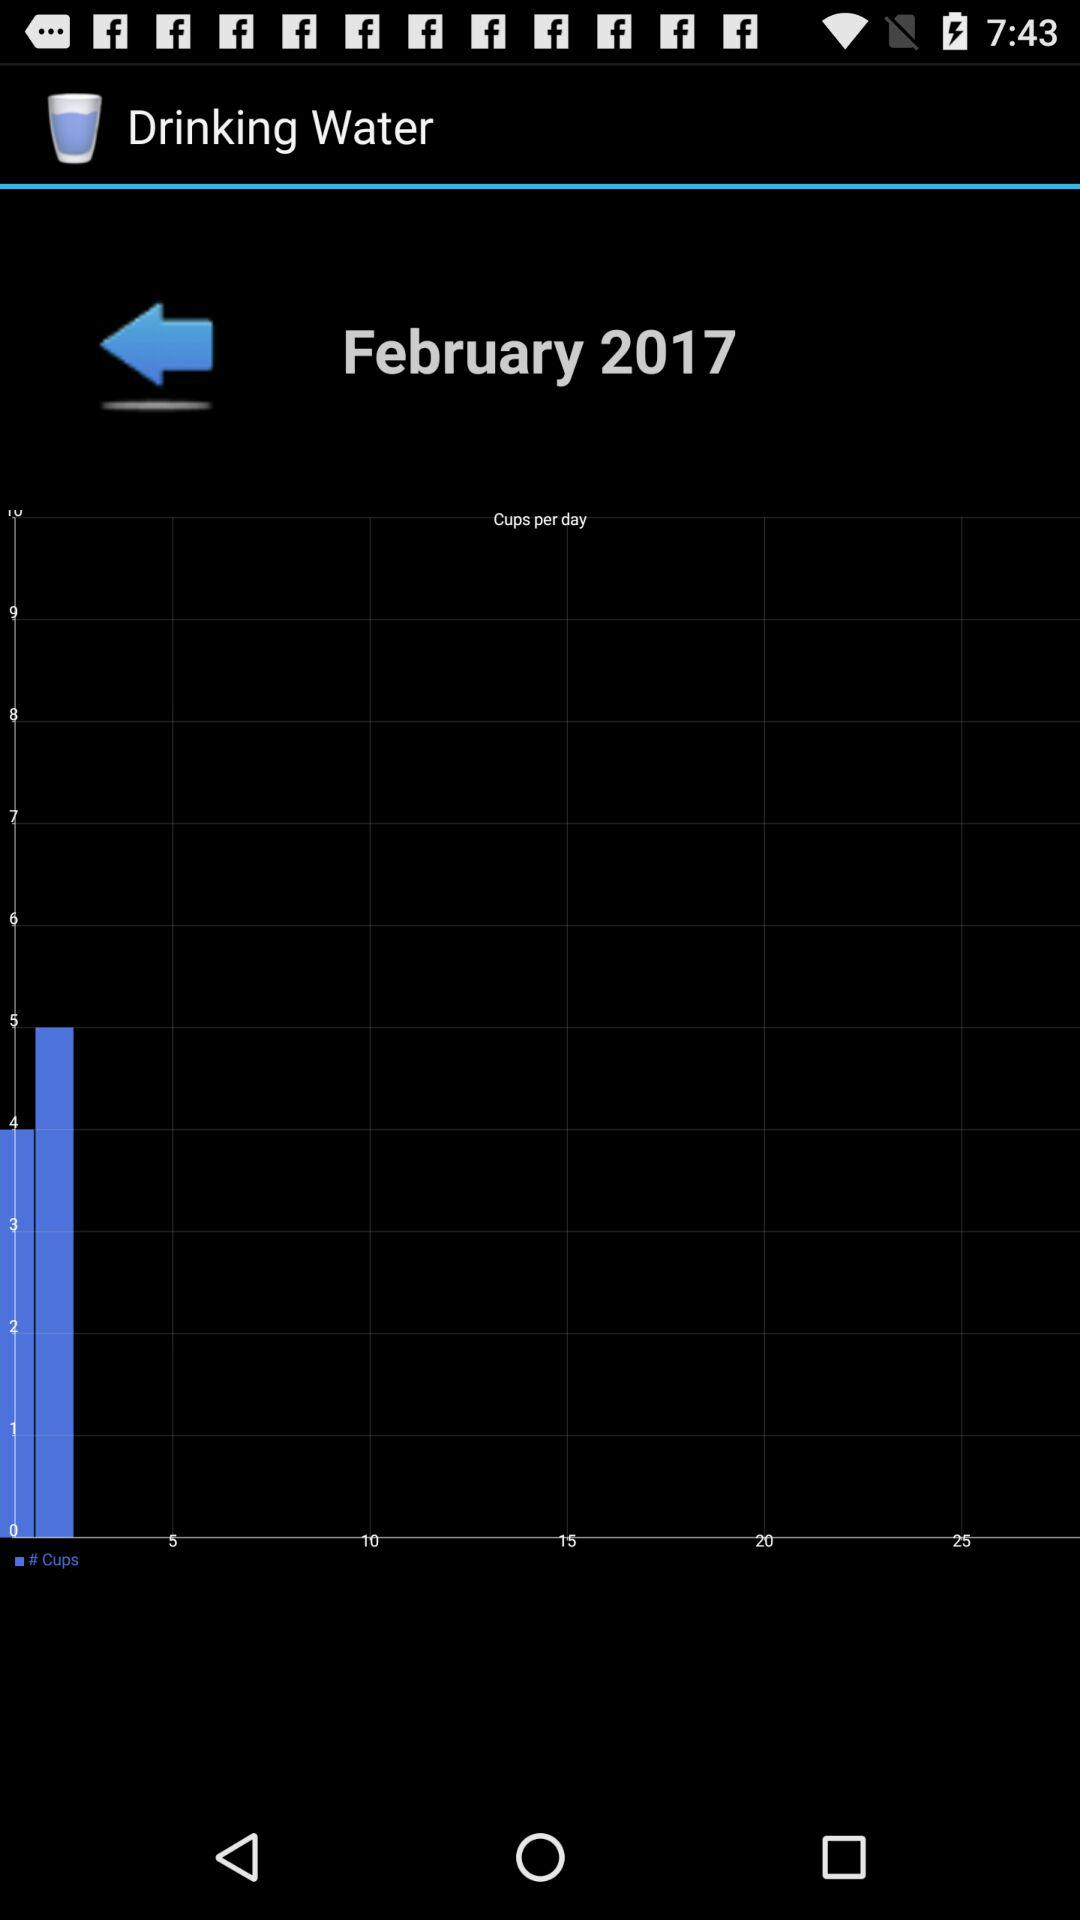How many days are there in the month shown in the screenshot?
Answer the question using a single word or phrase. 28 